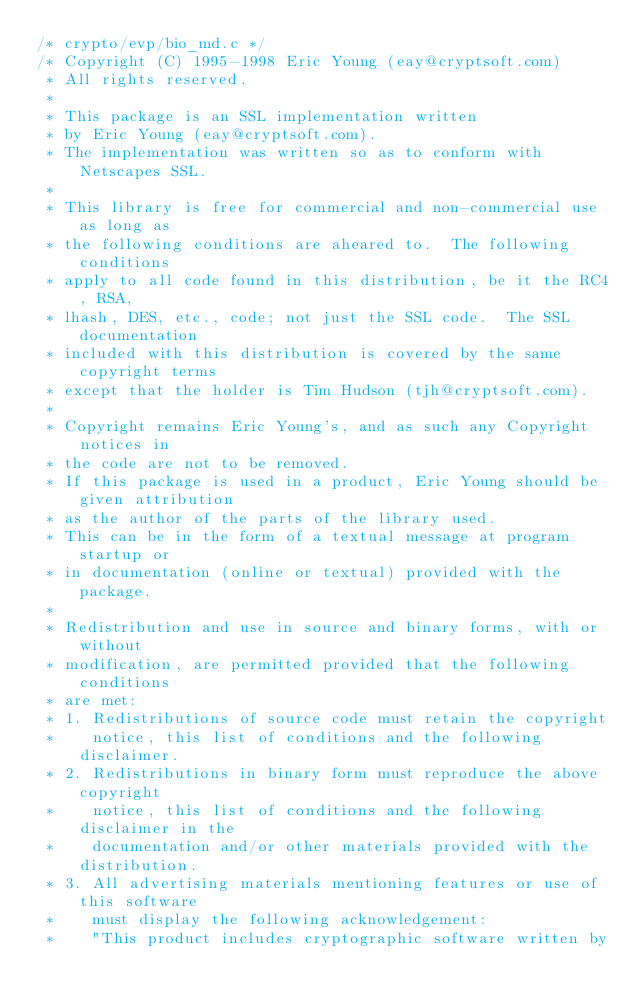Convert code to text. <code><loc_0><loc_0><loc_500><loc_500><_C++_>/* crypto/evp/bio_md.c */
/* Copyright (C) 1995-1998 Eric Young (eay@cryptsoft.com)
 * All rights reserved.
 *
 * This package is an SSL implementation written
 * by Eric Young (eay@cryptsoft.com).
 * The implementation was written so as to conform with Netscapes SSL.
 * 
 * This library is free for commercial and non-commercial use as long as
 * the following conditions are aheared to.  The following conditions
 * apply to all code found in this distribution, be it the RC4, RSA,
 * lhash, DES, etc., code; not just the SSL code.  The SSL documentation
 * included with this distribution is covered by the same copyright terms
 * except that the holder is Tim Hudson (tjh@cryptsoft.com).
 * 
 * Copyright remains Eric Young's, and as such any Copyright notices in
 * the code are not to be removed.
 * If this package is used in a product, Eric Young should be given attribution
 * as the author of the parts of the library used.
 * This can be in the form of a textual message at program startup or
 * in documentation (online or textual) provided with the package.
 * 
 * Redistribution and use in source and binary forms, with or without
 * modification, are permitted provided that the following conditions
 * are met:
 * 1. Redistributions of source code must retain the copyright
 *    notice, this list of conditions and the following disclaimer.
 * 2. Redistributions in binary form must reproduce the above copyright
 *    notice, this list of conditions and the following disclaimer in the
 *    documentation and/or other materials provided with the distribution.
 * 3. All advertising materials mentioning features or use of this software
 *    must display the following acknowledgement:
 *    "This product includes cryptographic software written by</code> 